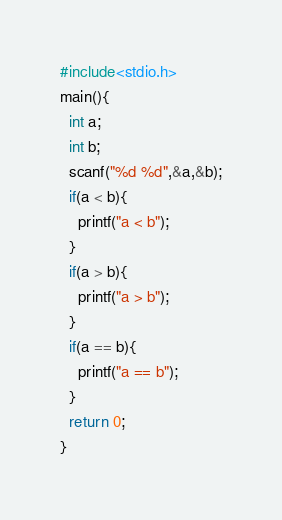<code> <loc_0><loc_0><loc_500><loc_500><_C_>#include<stdio.h>
main(){
  int a;
  int b;
  scanf("%d %d",&a,&b);
  if(a < b){
    printf("a < b");
  }
  if(a > b){
    printf("a > b");
  }
  if(a == b){
    printf("a == b");
  }
  return 0;
}</code> 